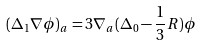Convert formula to latex. <formula><loc_0><loc_0><loc_500><loc_500>( \Delta _ { 1 } \nabla \phi ) _ { a } = 3 \nabla _ { a } ( \Delta _ { 0 } - \frac { 1 } { 3 } R ) \phi</formula> 